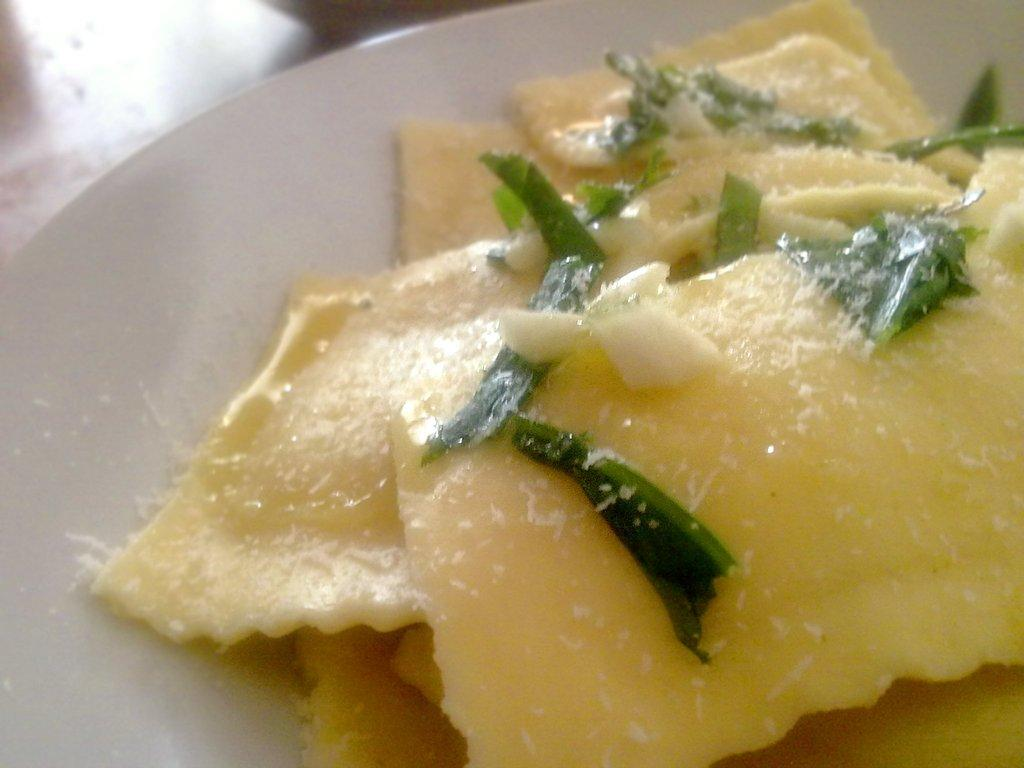What is present on the plate in the image? There are food items on the plate in the image. What is the color of the plate? The plate is white in color. How much money is being exchanged on the plate in the image? There is no money or exchange of money present on the plate in the image; it contains food items. What type of musical instrument is visible on the plate in the image? There is no musical instrument present on the plate in the image; it contains food items. 